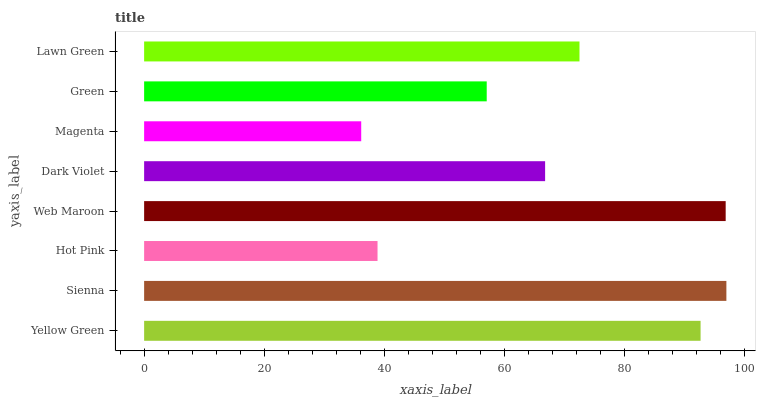Is Magenta the minimum?
Answer yes or no. Yes. Is Sienna the maximum?
Answer yes or no. Yes. Is Hot Pink the minimum?
Answer yes or no. No. Is Hot Pink the maximum?
Answer yes or no. No. Is Sienna greater than Hot Pink?
Answer yes or no. Yes. Is Hot Pink less than Sienna?
Answer yes or no. Yes. Is Hot Pink greater than Sienna?
Answer yes or no. No. Is Sienna less than Hot Pink?
Answer yes or no. No. Is Lawn Green the high median?
Answer yes or no. Yes. Is Dark Violet the low median?
Answer yes or no. Yes. Is Hot Pink the high median?
Answer yes or no. No. Is Lawn Green the low median?
Answer yes or no. No. 